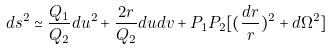Convert formula to latex. <formula><loc_0><loc_0><loc_500><loc_500>d s ^ { 2 } \simeq \frac { Q _ { 1 } } { Q _ { 2 } } d u ^ { 2 } + \frac { 2 r } { Q _ { 2 } } d u d v + P _ { 1 } P _ { 2 } [ ( \frac { d r } { r } ) ^ { 2 } + d \Omega ^ { 2 } ]</formula> 